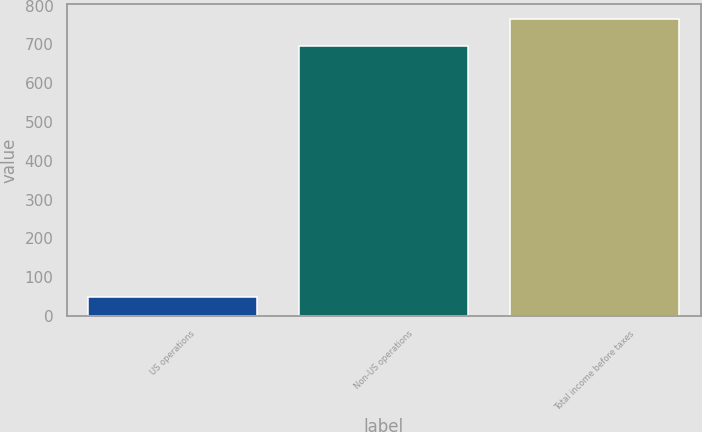Convert chart. <chart><loc_0><loc_0><loc_500><loc_500><bar_chart><fcel>US operations<fcel>Non-US operations<fcel>Total income before taxes<nl><fcel>50<fcel>696<fcel>765.6<nl></chart> 